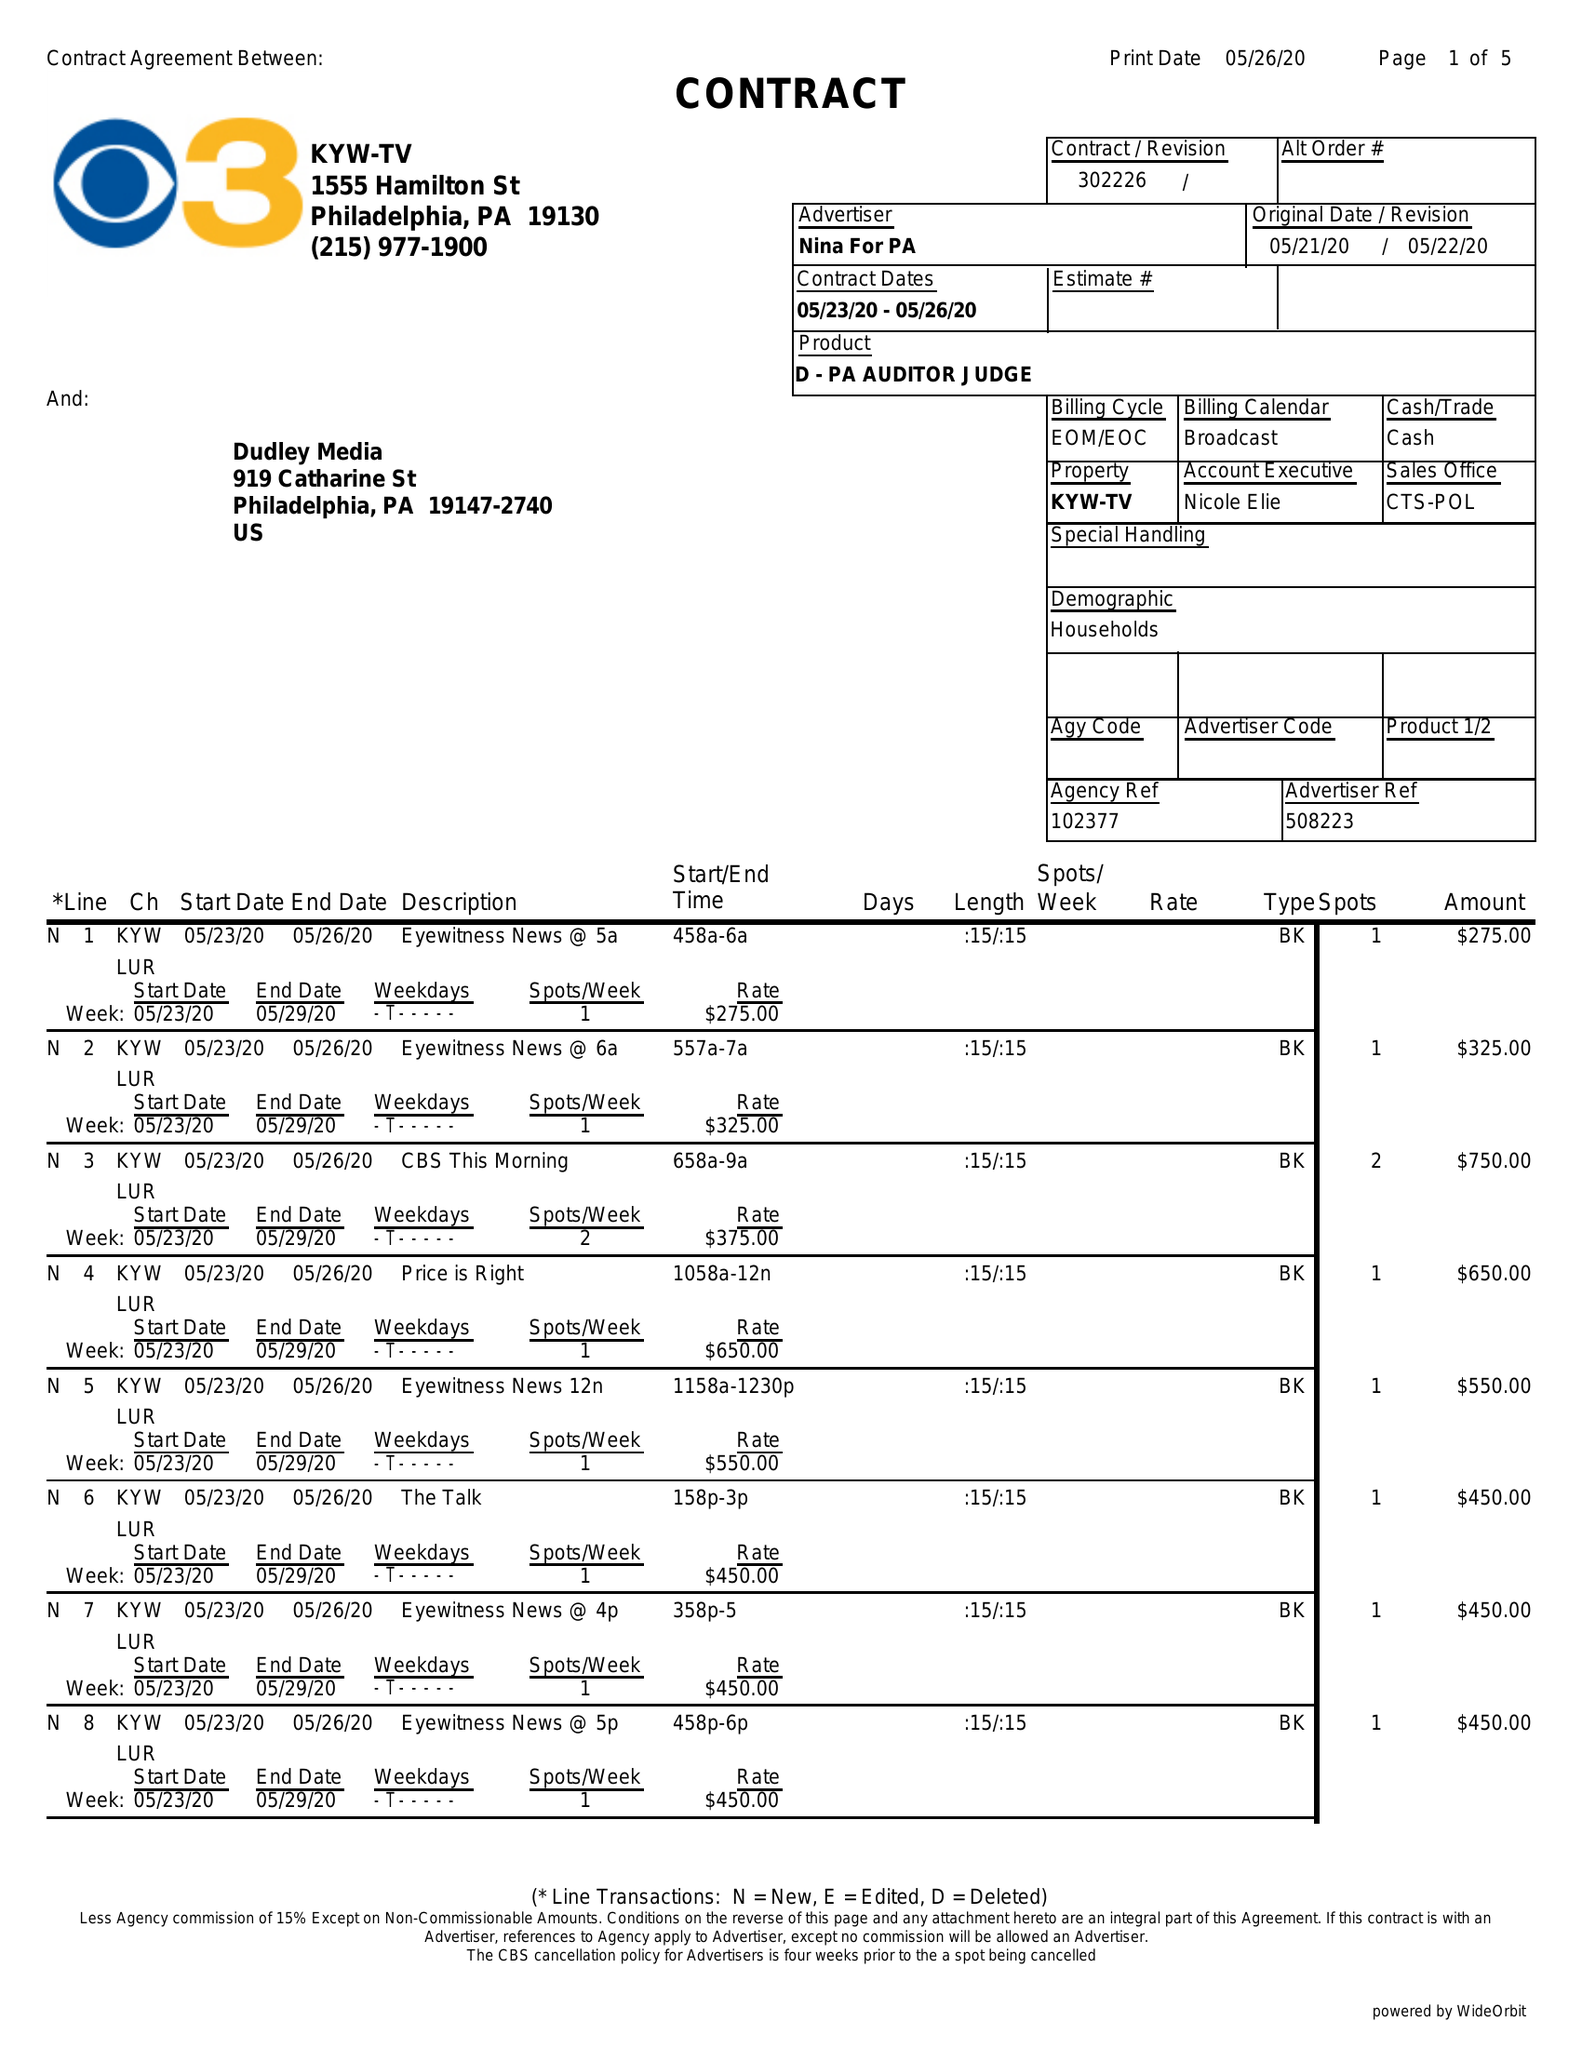What is the value for the advertiser?
Answer the question using a single word or phrase. NINA FOR PA 